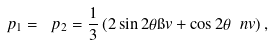<formula> <loc_0><loc_0><loc_500><loc_500>\ p _ { 1 } = \ p _ { 2 } = \frac { 1 } { 3 } \left ( 2 \sin 2 \theta \i v + \cos 2 \theta \ n v \right ) ,</formula> 